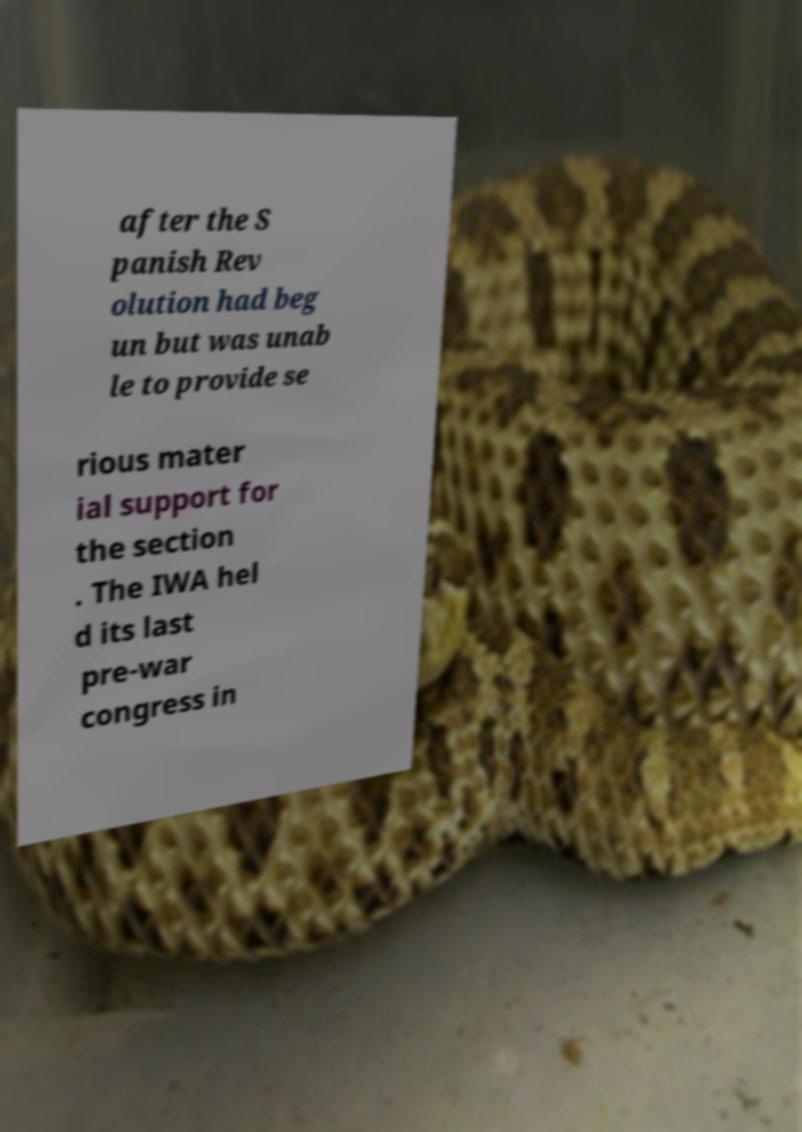I need the written content from this picture converted into text. Can you do that? after the S panish Rev olution had beg un but was unab le to provide se rious mater ial support for the section . The IWA hel d its last pre-war congress in 